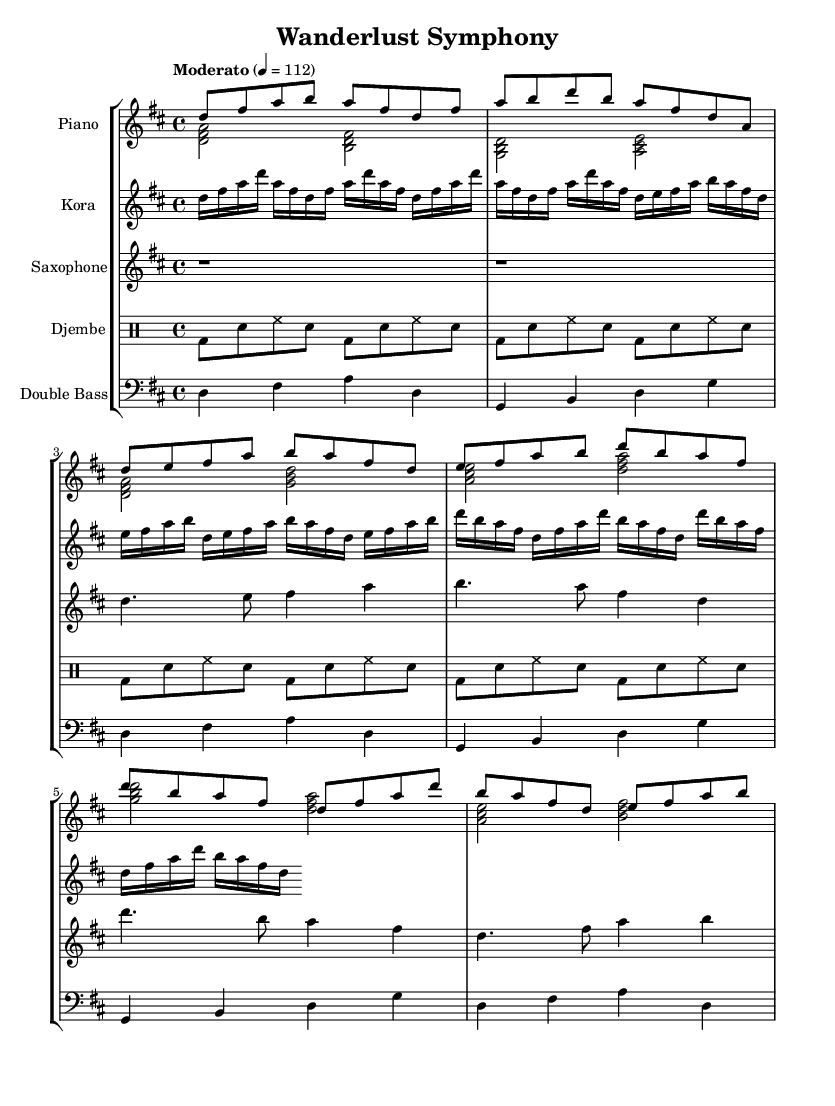What is the key signature of this music? The key signature is D major, which has two sharps (F# and C#). This can be determined by looking at the key signature notation at the beginning of the music staff.
Answer: D major What is the time signature of this music? The time signature is 4/4, indicated at the beginning of the score. This means there are four beats in a measure and the quarter note receives one beat.
Answer: 4/4 What is the tempo marking of this piece? The tempo marking is "Moderato," which is often understood to mean moderate speed, generally around 108-120 beats per minute. This is indicated in the tempo indication at the beginning of the music.
Answer: Moderato How many instruments are involved in this piece? There are five instruments: Piano, Kora, Saxophone, Djembe, and Double Bass. This can be identified by the number of staves represented in the score section.
Answer: Five Which section of the music is repeated for the Kora? The Kora part has sections that are repeated based on the "repeat unfold" indication before the notes. Specifically, both the intro and the verse sections are repeated twice.
Answer: Intro and Verse What is the main rhythmic pattern of the Djembe? The main rhythmic pattern is a combination of bass, snare, and hi-hat notes indicated in the percussion section. This specific pattern repeats throughout the piece.
Answer: Bass-snare pattern How does the saxophone contribute to the main theme? The saxophone plays the main theme in the verse and chorus sections, utilizing long notes with ties that create melodic continuity and interaction with other instruments.
Answer: Main theme 